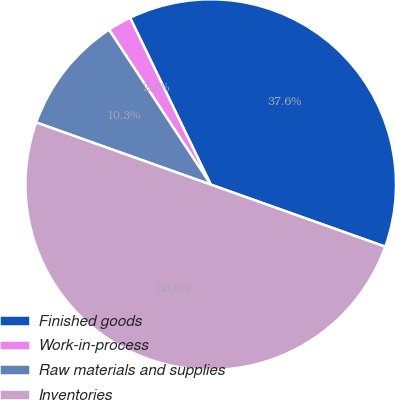Convert chart to OTSL. <chart><loc_0><loc_0><loc_500><loc_500><pie_chart><fcel>Finished goods<fcel>Work-in-process<fcel>Raw materials and supplies<fcel>Inventories<nl><fcel>37.61%<fcel>2.08%<fcel>10.31%<fcel>50.0%<nl></chart> 